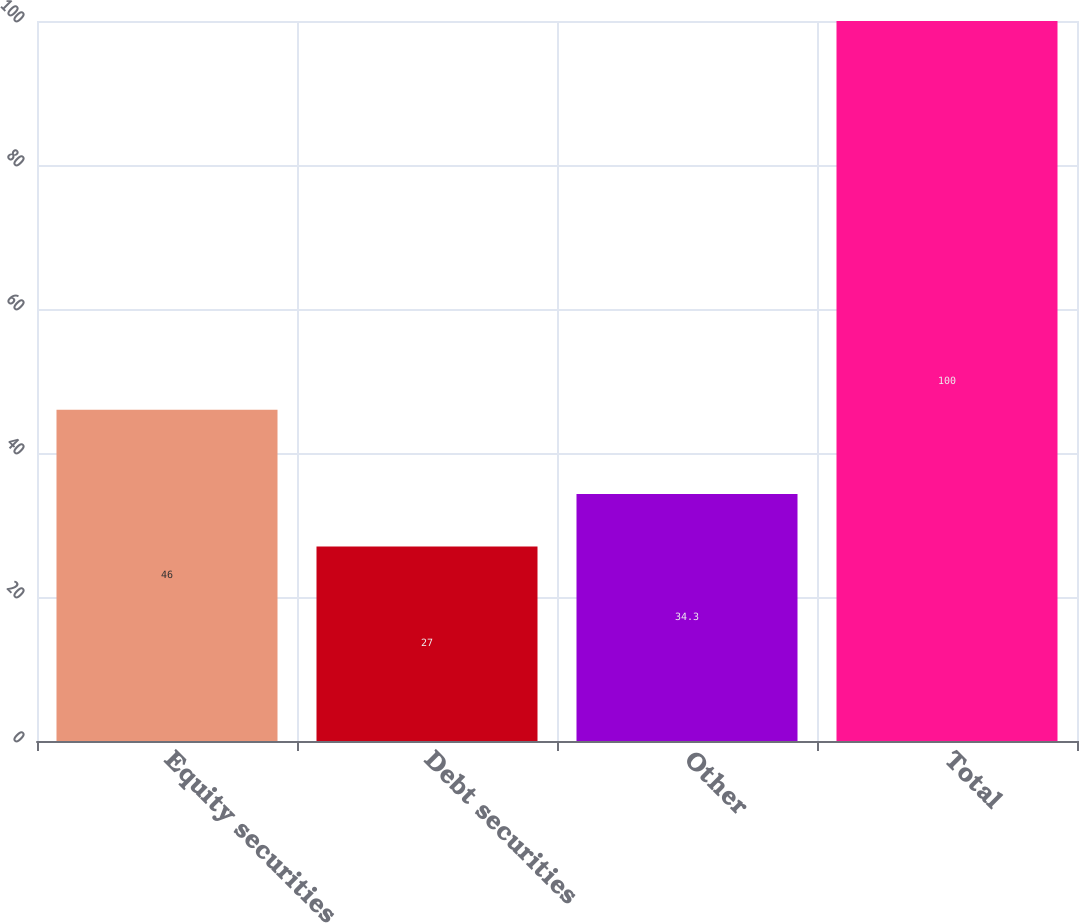Convert chart. <chart><loc_0><loc_0><loc_500><loc_500><bar_chart><fcel>Equity securities<fcel>Debt securities<fcel>Other<fcel>Total<nl><fcel>46<fcel>27<fcel>34.3<fcel>100<nl></chart> 